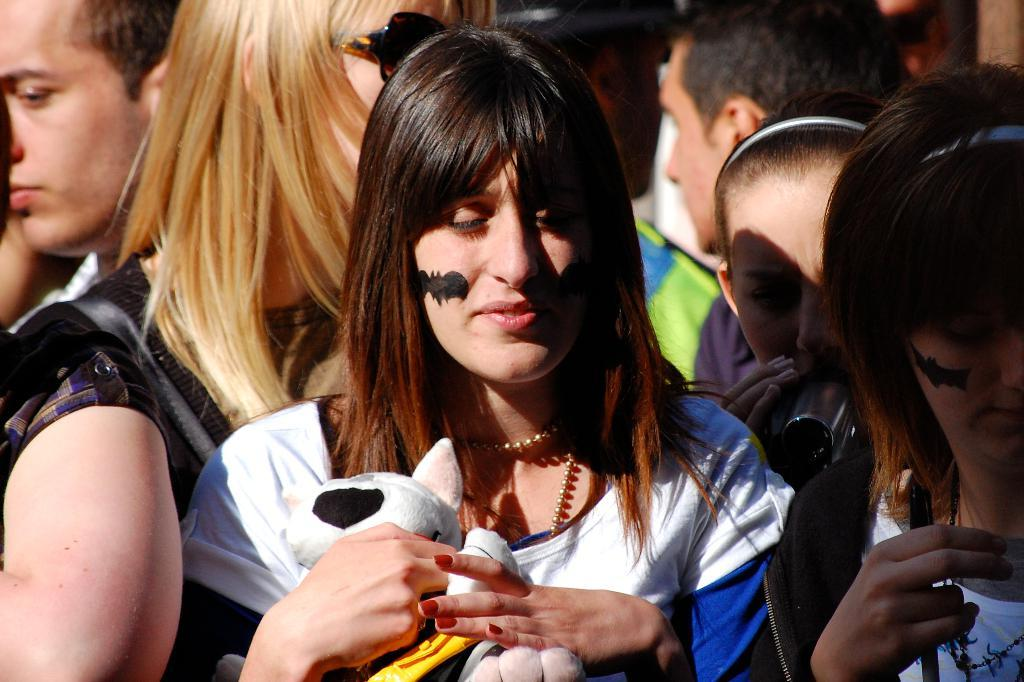How many people are present in the image? There are many people in the image. What is the lady holding in the image? The lady is holding a doll. Can you describe any unique features of the lady in the image? The lady has a painting of a bat on her face. What type of root can be seen growing from the doll in the image? There is no root growing from the doll in the image; it is a doll being held by the lady. 